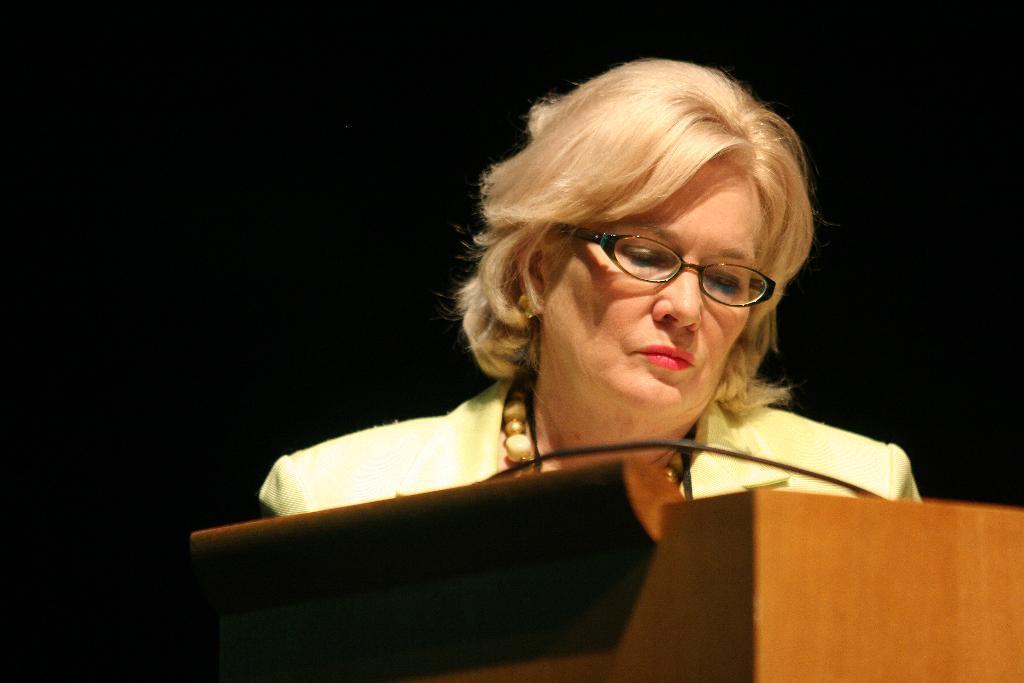In one or two sentences, can you explain what this image depicts? In the center of the picture there is a woman wearing a suit. In the foreground there is a podium. The background is dark. 